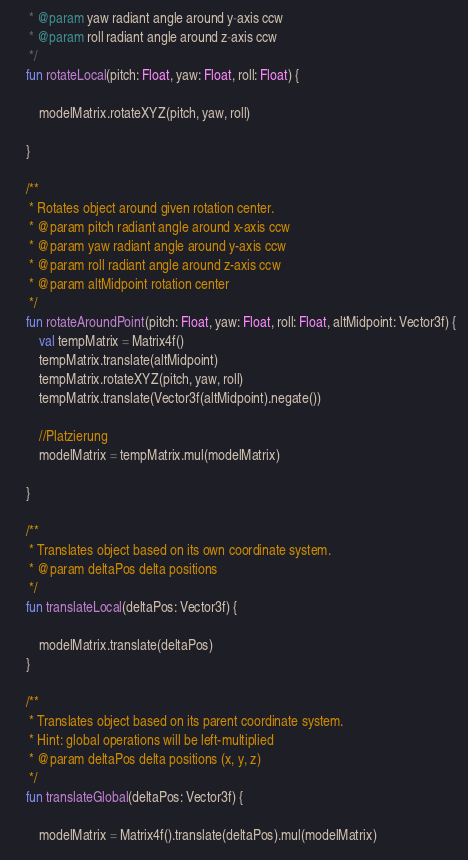<code> <loc_0><loc_0><loc_500><loc_500><_Kotlin_>     * @param yaw radiant angle around y-axis ccw
     * @param roll radiant angle around z-axis ccw
     */
    fun rotateLocal(pitch: Float, yaw: Float, roll: Float) {

        modelMatrix.rotateXYZ(pitch, yaw, roll)

    }

    /**
     * Rotates object around given rotation center.
     * @param pitch radiant angle around x-axis ccw
     * @param yaw radiant angle around y-axis ccw
     * @param roll radiant angle around z-axis ccw
     * @param altMidpoint rotation center
     */
    fun rotateAroundPoint(pitch: Float, yaw: Float, roll: Float, altMidpoint: Vector3f) {
        val tempMatrix = Matrix4f()
        tempMatrix.translate(altMidpoint)
        tempMatrix.rotateXYZ(pitch, yaw, roll)
        tempMatrix.translate(Vector3f(altMidpoint).negate())

        //Platzierung
        modelMatrix = tempMatrix.mul(modelMatrix)

    }

    /**
     * Translates object based on its own coordinate system.
     * @param deltaPos delta positions
     */
    fun translateLocal(deltaPos: Vector3f) {

        modelMatrix.translate(deltaPos)
    }

    /**
     * Translates object based on its parent coordinate system.
     * Hint: global operations will be left-multiplied
     * @param deltaPos delta positions (x, y, z)
     */
    fun translateGlobal(deltaPos: Vector3f) {

        modelMatrix = Matrix4f().translate(deltaPos).mul(modelMatrix)
</code> 